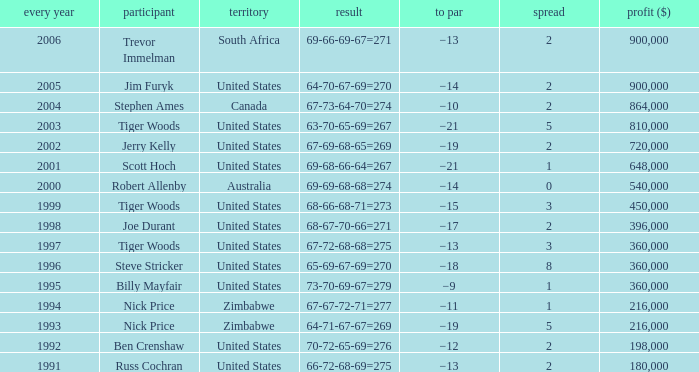How many years have a Player of joe durant, and Earnings ($) larger than 396,000? 0.0. 